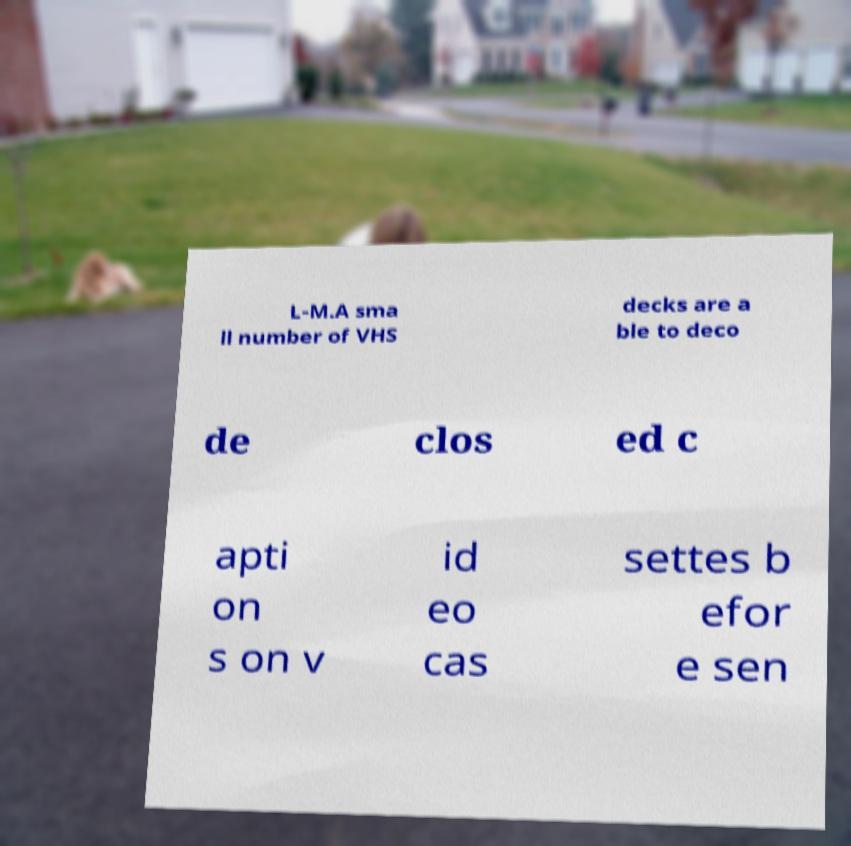Please read and relay the text visible in this image. What does it say? L-M.A sma ll number of VHS decks are a ble to deco de clos ed c apti on s on v id eo cas settes b efor e sen 